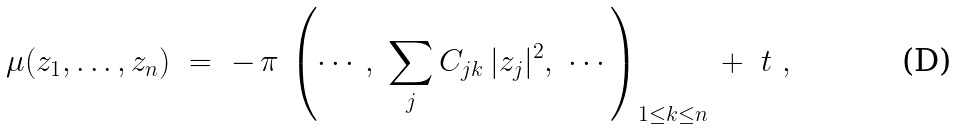<formula> <loc_0><loc_0><loc_500><loc_500>\mu ( z _ { 1 } , \dots , z _ { n } ) \ = \ - \, \pi \, \left ( \cdots , \ \sum _ { j } C _ { j k } \, | z _ { j } | ^ { 2 } , \ \cdots \right ) _ { 1 \leq k \leq n } \, + \ t \ ,</formula> 